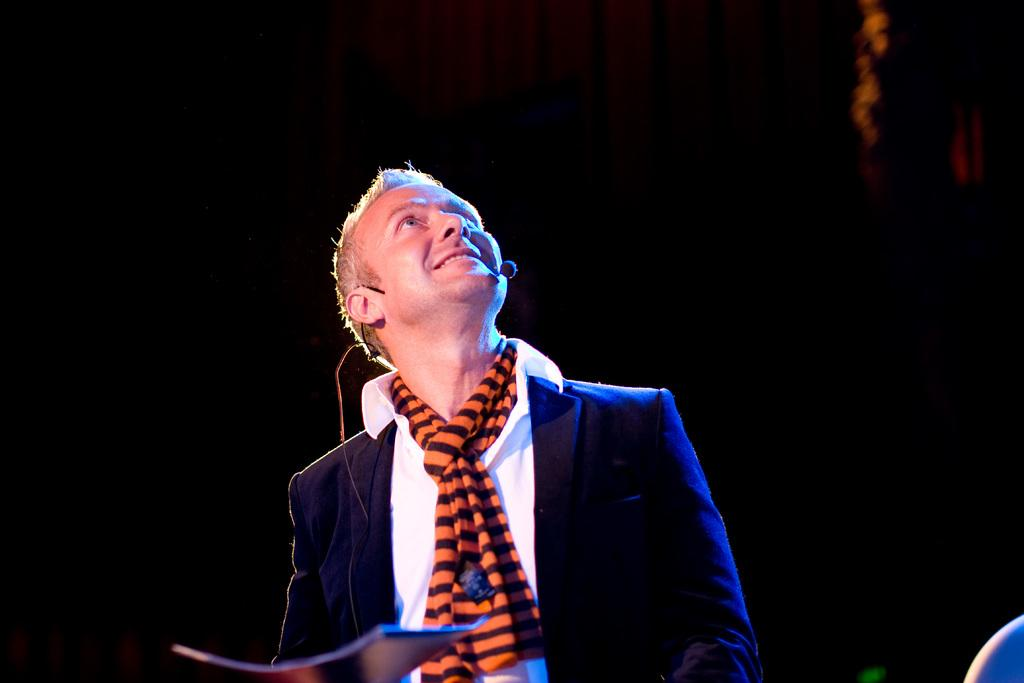Who or what is present in the image? There is a person in the image. What is the person wearing in the image? The person is wearing a microphone in the image. What type of canvas is visible in the image? There is no canvas present in the image. Is there a letter being read by the person in the image? There is no letter visible in the image. 